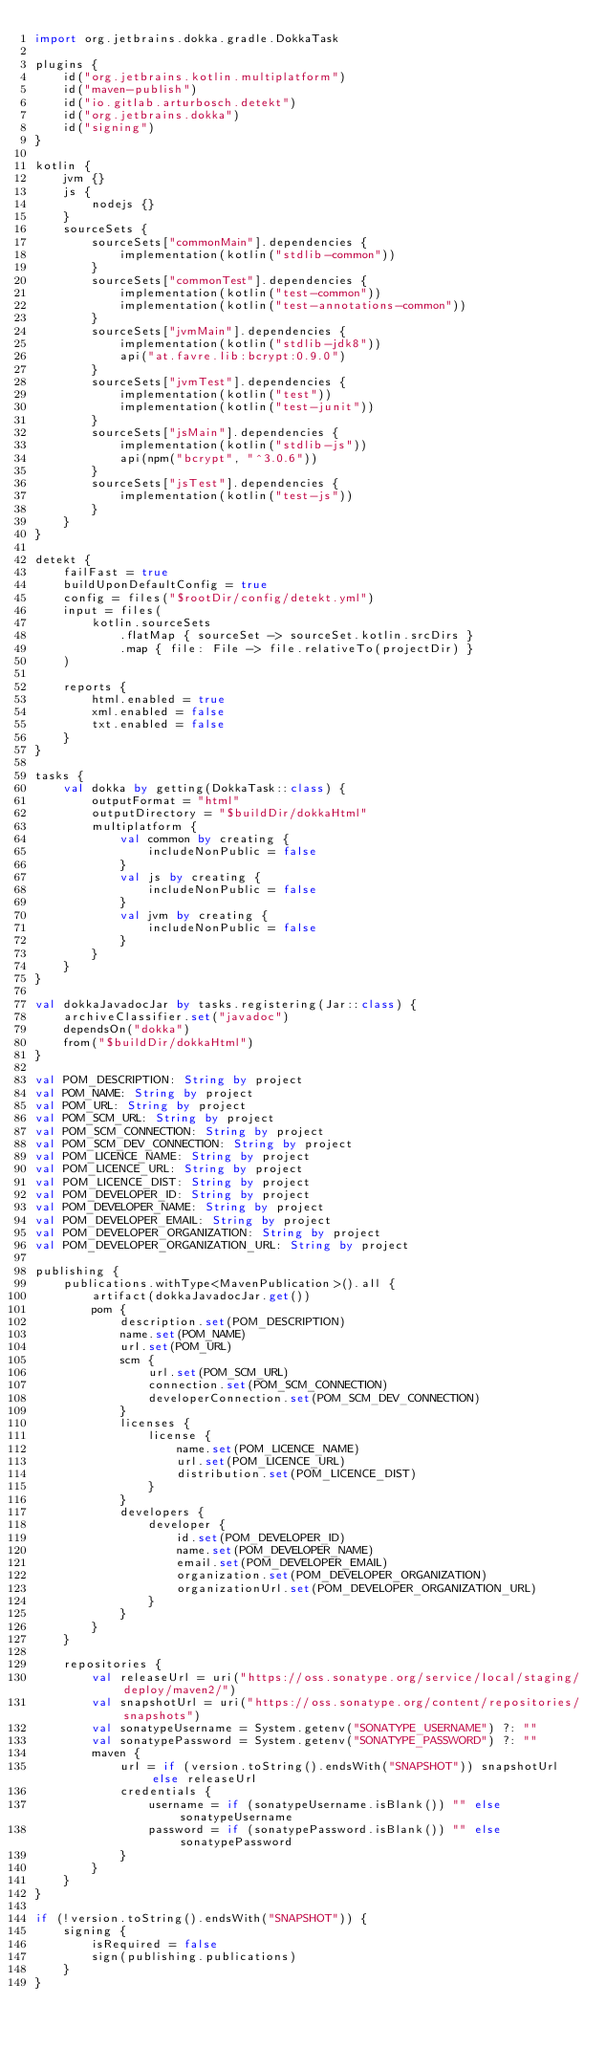<code> <loc_0><loc_0><loc_500><loc_500><_Kotlin_>import org.jetbrains.dokka.gradle.DokkaTask

plugins {
    id("org.jetbrains.kotlin.multiplatform")
    id("maven-publish")
    id("io.gitlab.arturbosch.detekt")
    id("org.jetbrains.dokka")
    id("signing")
}

kotlin {
    jvm {}
    js {
        nodejs {}
    }
    sourceSets {
        sourceSets["commonMain"].dependencies {
            implementation(kotlin("stdlib-common"))
        }
        sourceSets["commonTest"].dependencies {
            implementation(kotlin("test-common"))
            implementation(kotlin("test-annotations-common"))
        }
        sourceSets["jvmMain"].dependencies {
            implementation(kotlin("stdlib-jdk8"))
            api("at.favre.lib:bcrypt:0.9.0")
        }
        sourceSets["jvmTest"].dependencies {
            implementation(kotlin("test"))
            implementation(kotlin("test-junit"))
        }
        sourceSets["jsMain"].dependencies {
            implementation(kotlin("stdlib-js"))
            api(npm("bcrypt", "^3.0.6"))
        }
        sourceSets["jsTest"].dependencies {
            implementation(kotlin("test-js"))
        }
    }
}

detekt {
    failFast = true
    buildUponDefaultConfig = true
    config = files("$rootDir/config/detekt.yml")
    input = files(
        kotlin.sourceSets
            .flatMap { sourceSet -> sourceSet.kotlin.srcDirs }
            .map { file: File -> file.relativeTo(projectDir) }
    )

    reports {
        html.enabled = true
        xml.enabled = false
        txt.enabled = false
    }
}

tasks {
    val dokka by getting(DokkaTask::class) {
        outputFormat = "html"
        outputDirectory = "$buildDir/dokkaHtml"
        multiplatform {
            val common by creating {
                includeNonPublic = false
            }
            val js by creating {
                includeNonPublic = false
            }
            val jvm by creating {
                includeNonPublic = false
            }
        }
    }
}

val dokkaJavadocJar by tasks.registering(Jar::class) {
    archiveClassifier.set("javadoc")
    dependsOn("dokka")
    from("$buildDir/dokkaHtml")
}

val POM_DESCRIPTION: String by project
val POM_NAME: String by project
val POM_URL: String by project
val POM_SCM_URL: String by project
val POM_SCM_CONNECTION: String by project
val POM_SCM_DEV_CONNECTION: String by project
val POM_LICENCE_NAME: String by project
val POM_LICENCE_URL: String by project
val POM_LICENCE_DIST: String by project
val POM_DEVELOPER_ID: String by project
val POM_DEVELOPER_NAME: String by project
val POM_DEVELOPER_EMAIL: String by project
val POM_DEVELOPER_ORGANIZATION: String by project
val POM_DEVELOPER_ORGANIZATION_URL: String by project

publishing {
    publications.withType<MavenPublication>().all {
        artifact(dokkaJavadocJar.get())
        pom {
            description.set(POM_DESCRIPTION)
            name.set(POM_NAME)
            url.set(POM_URL)
            scm {
                url.set(POM_SCM_URL)
                connection.set(POM_SCM_CONNECTION)
                developerConnection.set(POM_SCM_DEV_CONNECTION)
            }
            licenses {
                license {
                    name.set(POM_LICENCE_NAME)
                    url.set(POM_LICENCE_URL)
                    distribution.set(POM_LICENCE_DIST)
                }
            }
            developers {
                developer {
                    id.set(POM_DEVELOPER_ID)
                    name.set(POM_DEVELOPER_NAME)
                    email.set(POM_DEVELOPER_EMAIL)
                    organization.set(POM_DEVELOPER_ORGANIZATION)
                    organizationUrl.set(POM_DEVELOPER_ORGANIZATION_URL)
                }
            }
        }
    }

    repositories {
        val releaseUrl = uri("https://oss.sonatype.org/service/local/staging/deploy/maven2/")
        val snapshotUrl = uri("https://oss.sonatype.org/content/repositories/snapshots")
        val sonatypeUsername = System.getenv("SONATYPE_USERNAME") ?: ""
        val sonatypePassword = System.getenv("SONATYPE_PASSWORD") ?: ""
        maven {
            url = if (version.toString().endsWith("SNAPSHOT")) snapshotUrl else releaseUrl
            credentials {
                username = if (sonatypeUsername.isBlank()) "" else sonatypeUsername
                password = if (sonatypePassword.isBlank()) "" else sonatypePassword
            }
        }
    }
}

if (!version.toString().endsWith("SNAPSHOT")) {
    signing {
        isRequired = false
        sign(publishing.publications)
    }
}
</code> 